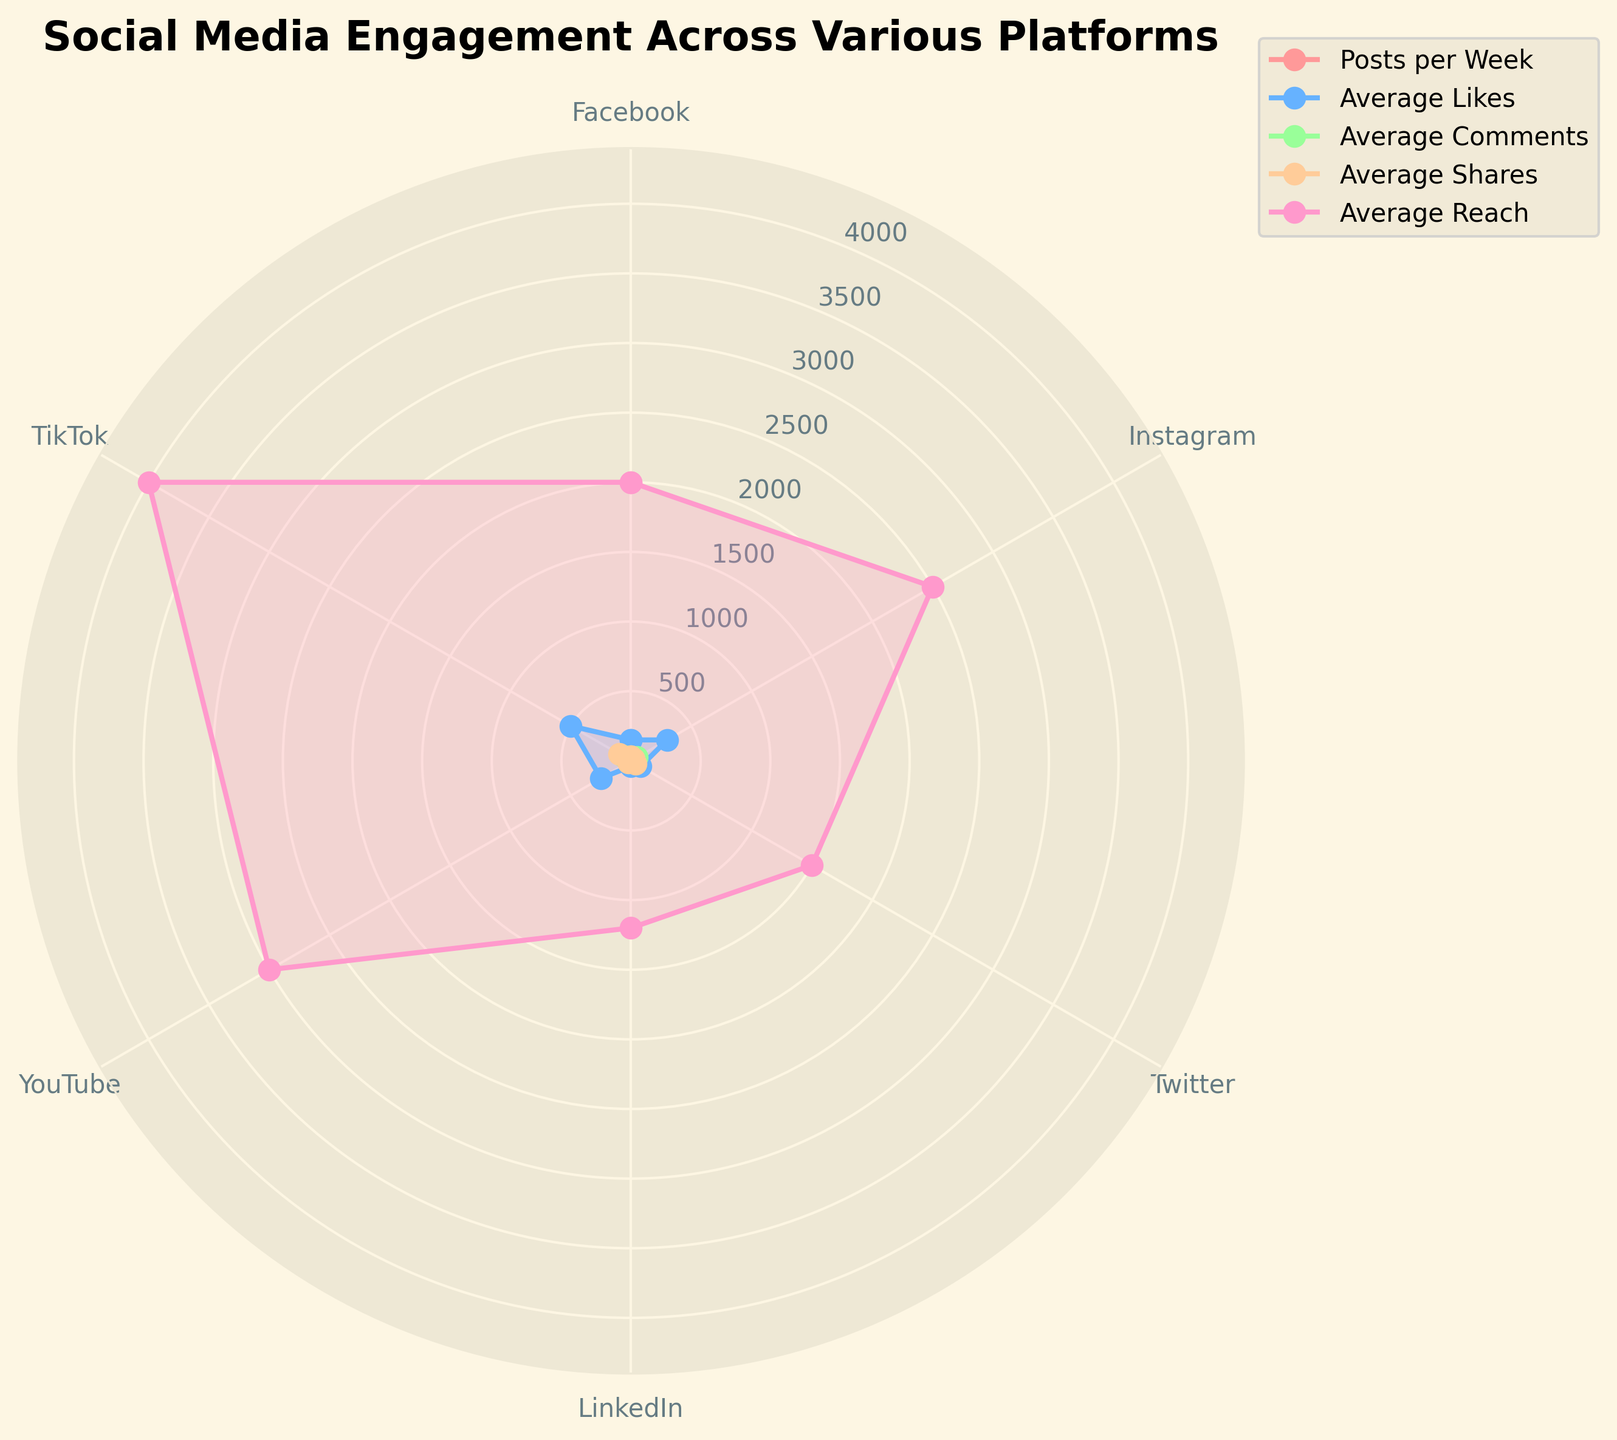What is the title of the radar chart? The title of the radar chart is typically displayed at the top center of the chart. For this figure, it reads "Social Media Engagement Across Various Platforms"
Answer: Social Media Engagement Across Various Platforms How many platforms are compared in the radar chart? By counting the number of different lines/colors on the radar chart and cross-referencing with the legend, we can see that there are six platforms compared.
Answer: Six Which platform has the highest average reach? By examining the maximum point along the "Average Reach" axis, we can see that the highest peak belongs to TikTok.
Answer: TikTok Which platform has the lowest number of posts per week? On the "Posts per Week" axis, locate the smallest value and track it back to its corresponding platform in the legend. LinkedIn has the lowest number of posts per week.
Answer: LinkedIn What is the average number of comments on Instagram? Follow the "Average Comments" axis to find the value corresponding to Instagram's plot in the radar chart. Instagram has 50 average comments.
Answer: 50 Which platform shows a higher average likes value, YouTube or Twitter? By comparing the values on the "Average Likes" axis for both YouTube and Twitter, we can see YouTube's value (250) is higher than Twitter's (80).
Answer: YouTube What is the combined average likes and shares for Facebook? Look at the values on the "Average Likes" and "Average Shares" axes for Facebook – 150 likes and 30 shares. Adding them together gives us 150 + 30 = 180.
Answer: 180 Does TikTok or Instagram have a higher average number of comments? Compare the values for the "Average Comments" axis for both TikTok and Instagram. TikTok has 70, whereas Instagram has 50. TikTok has a higher average number of comments.
Answer: TikTok What is the total number of posts per week across all platforms? Sum the values along the "Posts per Week" axis for all platforms: 10 (Facebook) + 12 (Instagram) + 15 (Twitter) + 8 (LinkedIn) + 5 (YouTube) + 20 (TikTok) = 70.
Answer: 70 Is the average number of shares on LinkedIn greater than the average number of comments on Facebook? Find the values on the "Average Shares" axis for LinkedIn (5) and the "Average Comments" axis for Facebook (25). Compare the two: 5 is not greater than 25.
Answer: No 